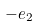Convert formula to latex. <formula><loc_0><loc_0><loc_500><loc_500>- e _ { 2 }</formula> 